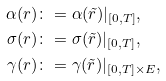<formula> <loc_0><loc_0><loc_500><loc_500>\alpha ( r ) & \colon = \alpha ( \tilde { r } ) | _ { [ 0 , T ] } , \\ \sigma ( r ) & \colon = \sigma ( \tilde { r } ) | _ { [ 0 , T ] } , \\ \gamma ( r ) & \colon = \gamma ( \tilde { r } ) | _ { [ 0 , T ] \times E } ,</formula> 